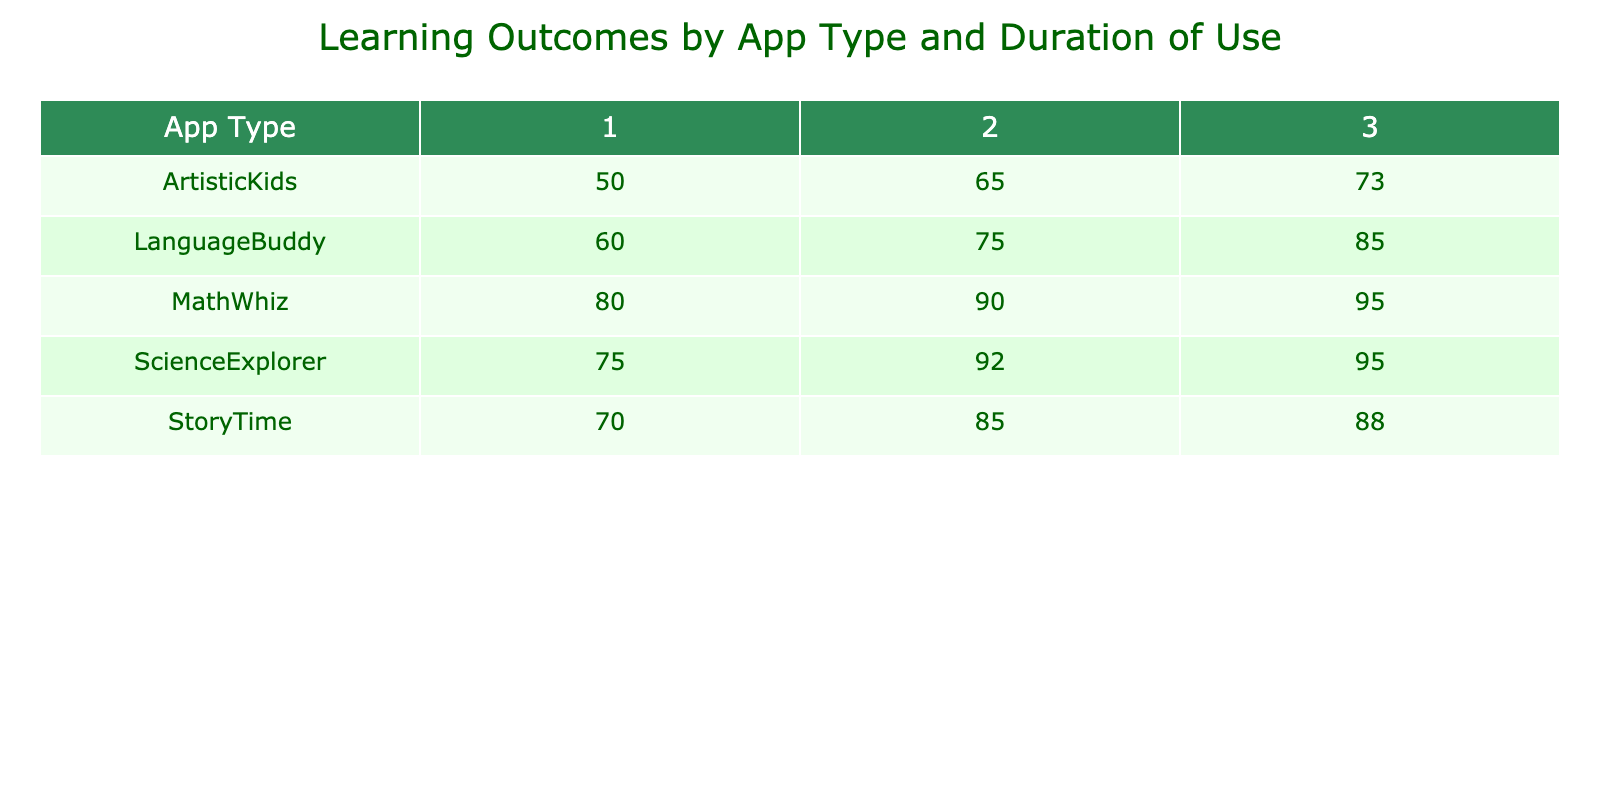What is the learning outcome for the LanguageBuddy app after 3 hours of use? Looking at the table, the value in the 'LanguageBuddy' row and the '3' column directly gives us the learning outcome for that app and duration, which is 85.
Answer: 85 Which app had the highest learning outcome at 2 hours of use? Comparing the values under the '2' column for all apps, we see that 'ScienceExplorer' has the highest value of 92.
Answer: ScienceExplorer What is the average learning outcome for children using the MathWhiz app? The learning outcomes for 'MathWhiz' are 80, 90, and 95. Adding these gives 80 + 90 + 95 = 265. There are 3 data points, so the average is 265 / 3 = 88.33, which we can round to 88.
Answer: 88 Is it true that the learning outcome increases with more hours of use for the ArtisticKids app? For 'ArtisticKids', the outcomes are 50, 65, and 73 for durations of 1, 2, and 3 hours. Since these values are increasing as the hours extend, it is true that the learning outcome increases with more hours of use.
Answer: Yes What is the difference in learning outcome between the highest and lowest for ScienceExplorer? The highest learning outcome for 'ScienceExplorer' is 95 (at 2 and 3 hours) and the lowest is 75 (at 1 hour). Thus, the difference is 95 - 75 = 20.
Answer: 20 Which app has a learning outcome of 70, and how does it compare to the LanguageBuddy app's learning outcome at 1 hour? The learning outcome of 70 belongs to 'StoryTime' at 1 hour. The learning outcome for 'LanguageBuddy' at 1 hour is 60. Therefore, 'StoryTime' has 10 points higher than 'LanguageBuddy' at 1 hour.
Answer: StoryTime, 10 points higher What is the total learning outcome when combining the outcomes for 3 hours of use across all apps? The learning outcomes at 3 hours are 95 (MathWhiz) + 88 (StoryTime) + 95 (ScienceExplorer) + 85 (LanguageBuddy) + 73 (ArtisticKids) = 436.
Answer: 436 Does using the ScienceExplorer app for 1 hour yield a higher learning outcome than using LanguageBuddy for 2 hours? The learning outcomes are 75 for 'ScienceExplorer' at 1 hour and 75 for 'LanguageBuddy' at 2 hours, which means they are equal, not higher.
Answer: No What is the highest learning outcome achieved across all apps and durations? Upon reviewing the table, the highest single value is 95 for both 'MathWhiz' and 'ScienceExplorer' at 3 hours.
Answer: 95 